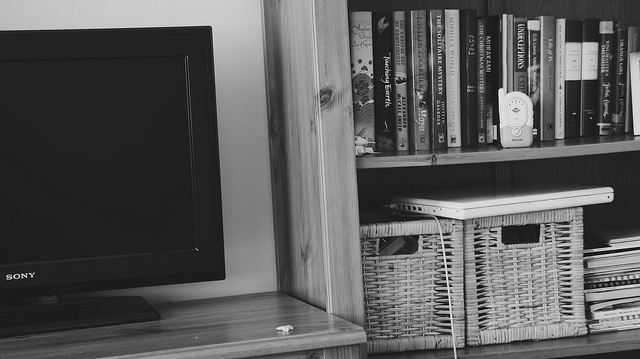Describe the objects in this image and their specific colors. I can see tv in lightgray, black, gray, and darkgray tones, book in lightgray, black, darkgray, and gray tones, laptop in lightgray, black, darkgray, and gray tones, book in lightgray, gray, and black tones, and book in lightgray, black, gray, and darkgray tones in this image. 